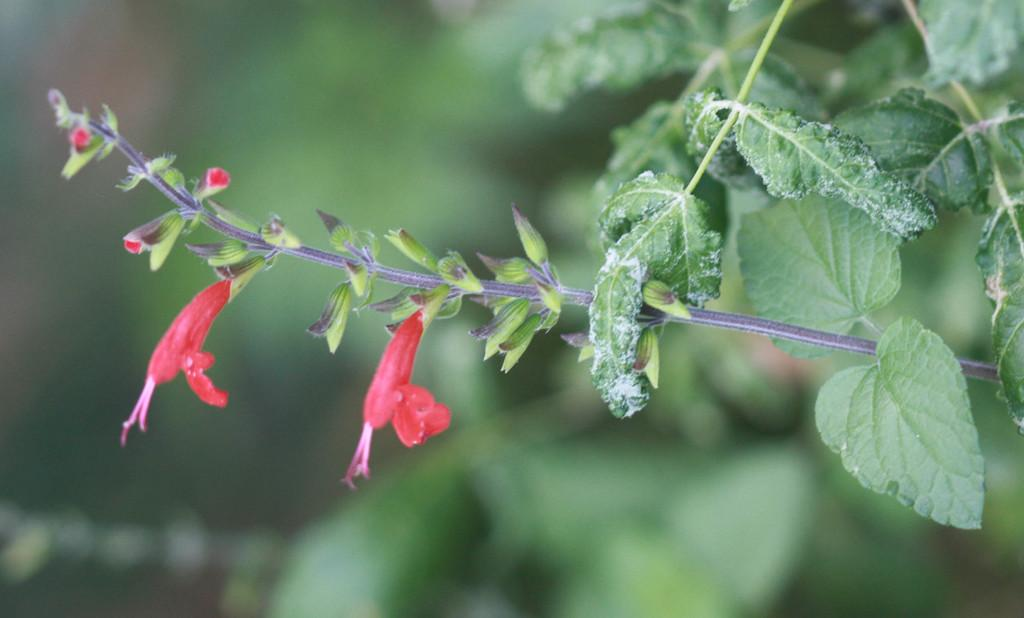What type of living organism is present in the image? There is a plant in the image. What specific features can be observed on the plant? The plant has flowers and buds. Can you describe the background of the image? The background of the image is blurred. What type of glove can be seen hanging from the plant in the image? There is no glove present in the image; it features a plant with flowers and buds. How many bananas are visible on the plant in the image? There are no bananas present in the image; it features a plant with flowers and buds. 